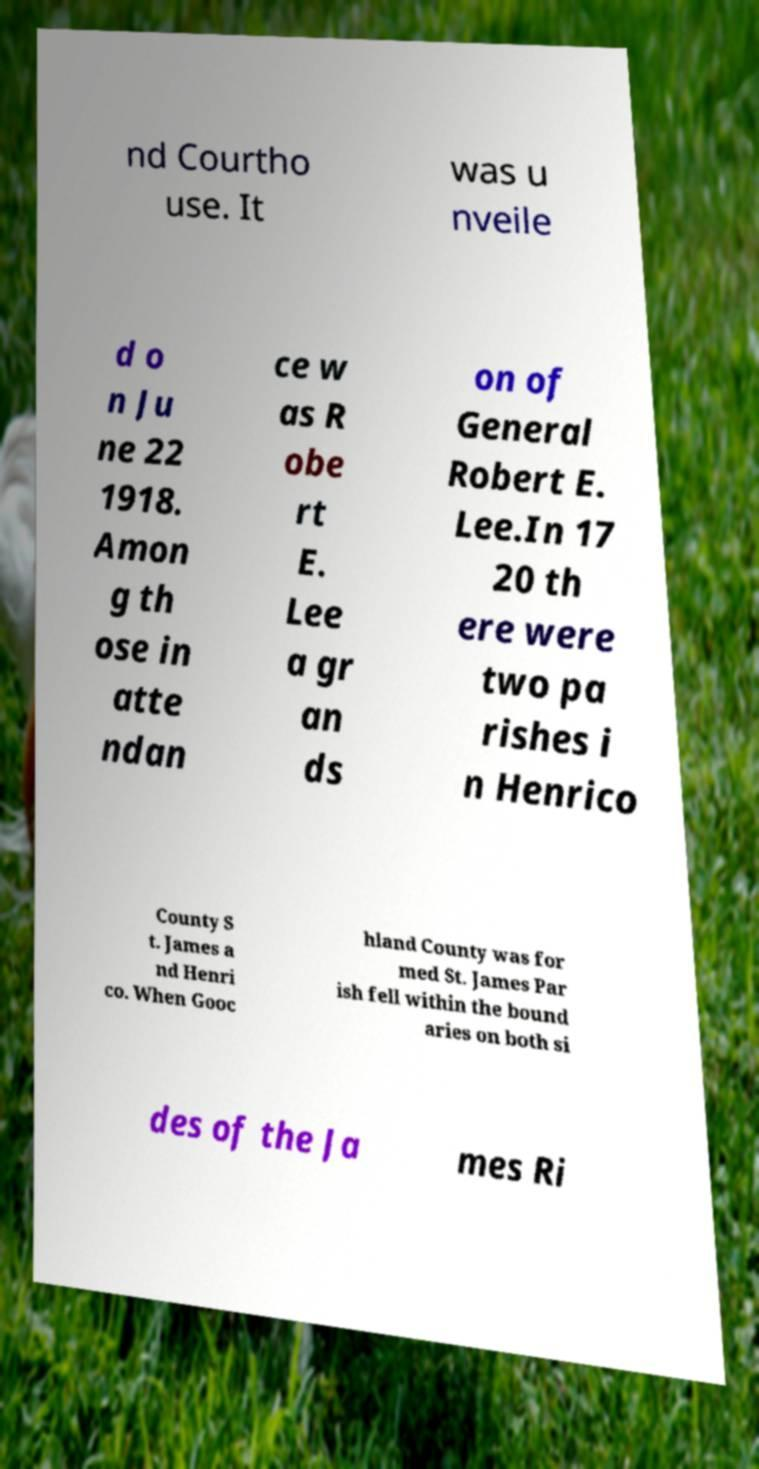What messages or text are displayed in this image? I need them in a readable, typed format. nd Courtho use. It was u nveile d o n Ju ne 22 1918. Amon g th ose in atte ndan ce w as R obe rt E. Lee a gr an ds on of General Robert E. Lee.In 17 20 th ere were two pa rishes i n Henrico County S t. James a nd Henri co. When Gooc hland County was for med St. James Par ish fell within the bound aries on both si des of the Ja mes Ri 